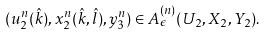<formula> <loc_0><loc_0><loc_500><loc_500>( u _ { 2 } ^ { n } ( \hat { k } ) , x _ { 2 } ^ { n } ( \hat { k } , \hat { l } ) , y _ { 3 } ^ { n } ) \in A _ { \epsilon } ^ { ( n ) } ( U _ { 2 } , X _ { 2 } , Y _ { 2 } ) .</formula> 